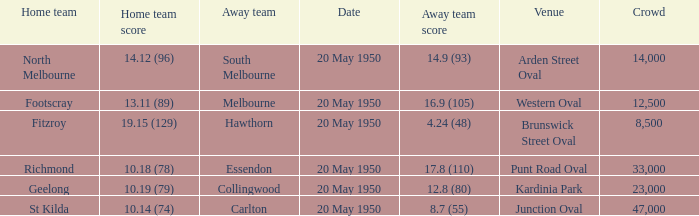What was the largest crowd to view a game where the away team scored 17.8 (110)? 33000.0. 